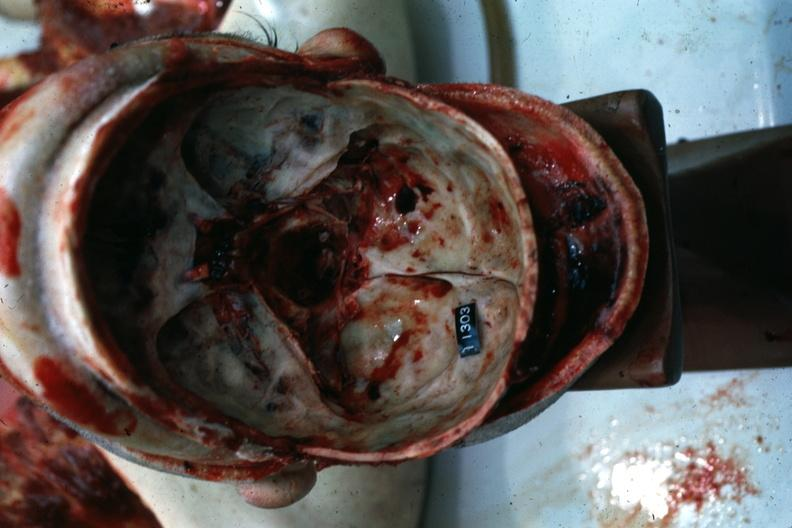s bone, calvarium present?
Answer the question using a single word or phrase. Yes 